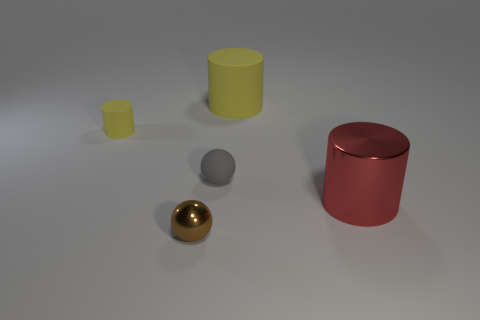How do the textures of the objects differ? From the image, the yellow cube and cylinder have a matte-like texture, indicating they absorb and diffuse light. The golden sphere and the red cylinder, however, have reflective surfaces that mirror the environment, highlighting a smooth and shiny texture. 